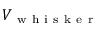Convert formula to latex. <formula><loc_0><loc_0><loc_500><loc_500>V _ { w h i s k e r }</formula> 